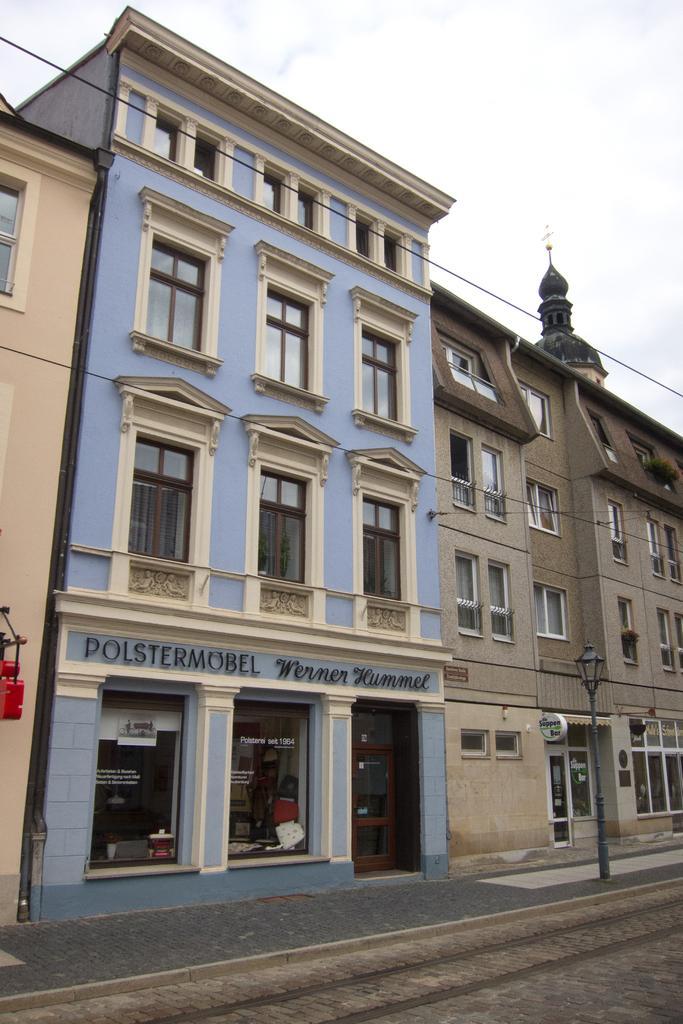In one or two sentences, can you explain what this image depicts? In this image there is the sky truncated towards the top of the image, there are buildings, there is a building truncated towards the right of the image, there is a building truncated towards the left of the image, there are windows, there is text on the building, there is an object truncated towards the left of the image, there is a pole, there is a street light, there is door, there are glass walls, there is text on the glass walls, at the bottom of the image there is the road truncated. 